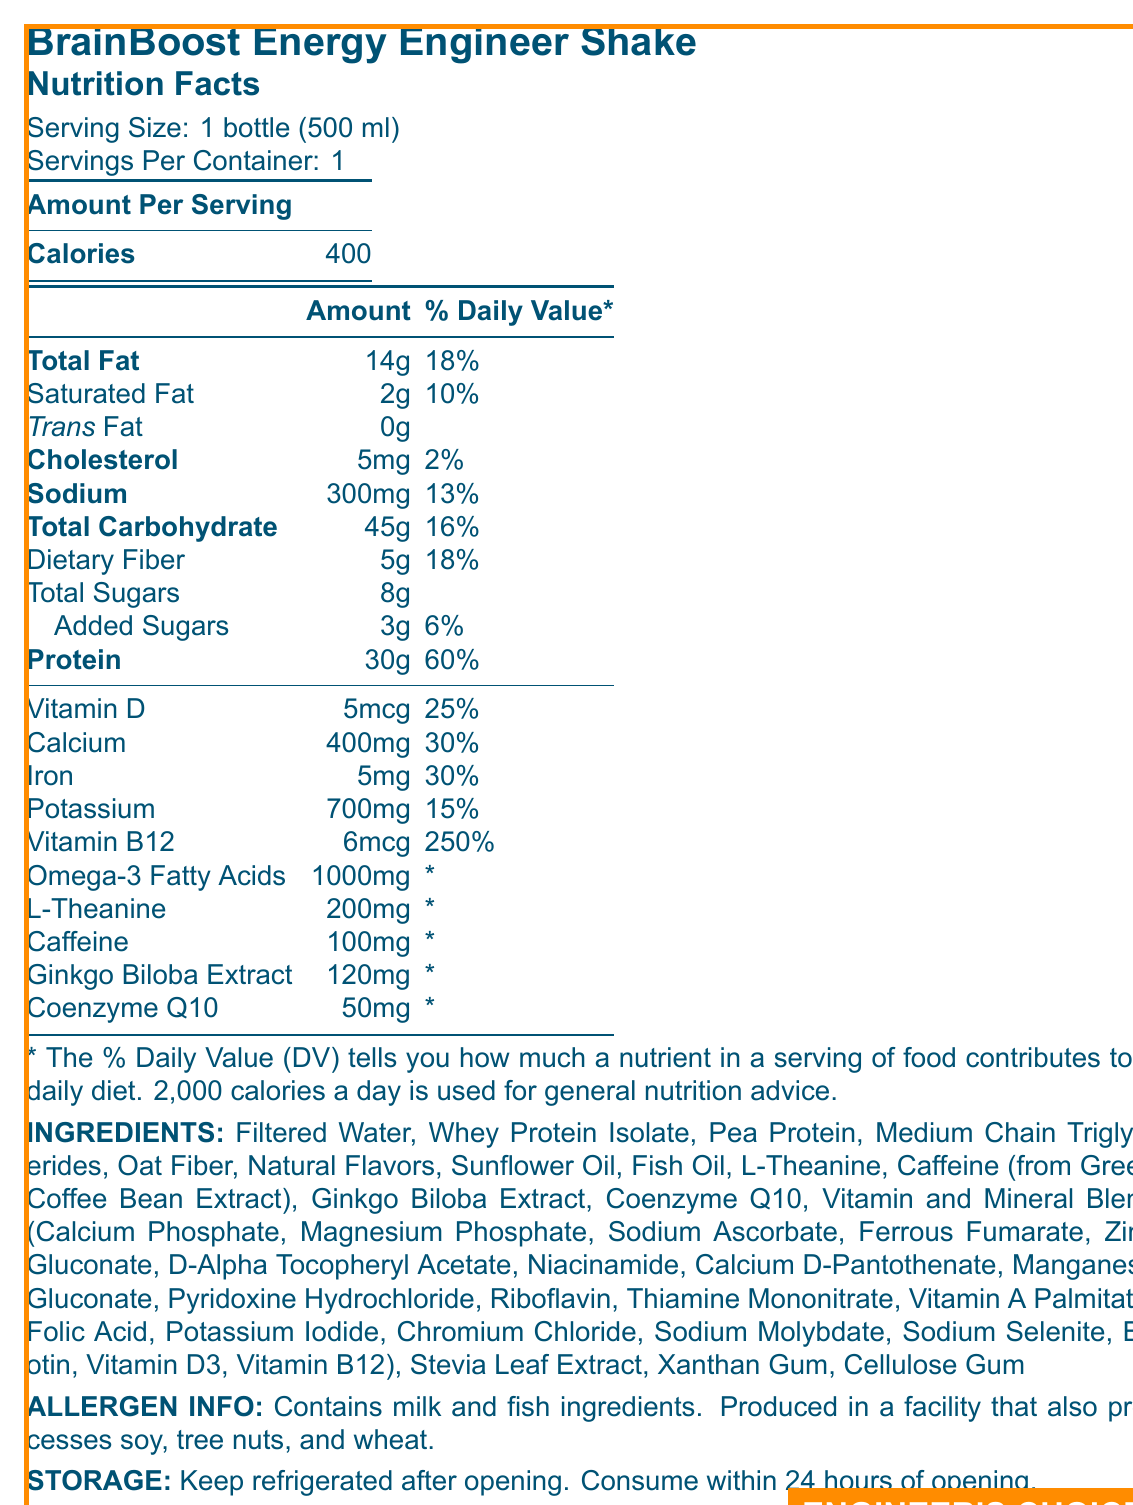what is the serving size? The document states that the serving size is 1 bottle (500 ml).
Answer: 1 bottle (500 ml) how many calories are there per serving? According to the document, each serving of the BrainBoost Energy Engineer Shake contains 400 calories.
Answer: 400 what percentage of the daily value of protein is in one serving? The document shows that one serving contains 30g of protein, which is 60% of the daily value.
Answer: 60% how much vitamin B12 is in one serving? The nutrition label indicates that there are 6mcg of vitamin B12 in one serving.
Answer: 6mcg which ingredients contain allergens? The allergen info section specifies that the shake contains milk and fish ingredients.
Answer: Milk and Fish what type of protein is used in the shake? A. Soy Protein B. Pea Protein C. Casein Protein D. Whey Protein Isolate The ingredients list includes Whey Protein Isolate and Pea Protein.
Answer: B and D what percentage of the daily value of vitamin D does one serving provide? A. 15% B. 25% C. 30% D. 50% The document indicates that one serving contains 5mcg of vitamin D, which is 25% of the daily value.
Answer: B is there any trans fat in the shake? The document lists 0g of trans fat in the nutritional information.
Answer: No does the product contain artificial sweeteners? The document lists Stevia Leaf Extract as a natural sweetener, not an artificial one.
Answer: No summarize the content and purpose of the document. The document provides a comprehensive summary of the ingredients, nutritional content, and benefits of the BrainBoost Energy Engineer Shake, highlighting its suitability for engineers needing cognitive support.
Answer: The document is a nutrition facts label for a meal replacement shake called BrainBoost Energy Engineer Shake. The label provides detailed nutritional information, ingredients list, allergen info, and storage instructions. The shake is designed to support cognitive function in engineers working on complex energy projects and contains various vitamins, minerals, and special ingredients like omega-3 fatty acids, L-theanine, and ginkgo biloba extract. what is the source of caffeine in the shake? The document specifies that caffeine is derived from Green Coffee Bean Extract.
Answer: Green Coffee Bean Extract how much dietary fiber does one serving provide? The nutritional information lists that one serving contains 5g of dietary fiber, which is 18% of the daily value.
Answer: 5g is the product suitable for individuals with soy allergies? The allergen info states that the product is produced in a facility that also processes soy, which may pose a risk for individuals with soy allergies.
Answer: No what is the manufacturer’s location? The document states that the manufacturer is EnergyMind Nutrition based in Houston, TX 77002.
Answer: Houston, TX 77002 is this product intended for people who follow a vegan diet? The shake contains milk and fish ingredients, making it unsuitable for a vegan diet.
Answer: No how many servings are in one container? A. 1 B. 2 C. 3 D. 4 The document specifies that there is 1 serving per container.
Answer: A what is the primary purpose of the BrainBoost Energy Engineer Shake? The document mentions that the shake is formulated to support cognitive function specifically for engineers tackling complex energy projects.
Answer: To support cognitive function in engineers working on complex energy projects is the percentage of daily value for omega-3 fatty acids provided? The document indicates omega-3 fatty acids amount in mg but does not provide a daily value percentage.
Answer: No how much calcium is in one serving? A. 100mg B. 200mg C. 400mg D. 600mg The document specifies that one serving contains 400mg of calcium, which is 30% of the daily value.
Answer: C what are the storage instructions for the BrainBoost Energy Engineer Shake? The storage section advises keeping the product refrigerated after opening and consuming it within 24 hours.
Answer: Keep refrigerated after opening. Consume within 24 hours of opening. 